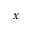<formula> <loc_0><loc_0><loc_500><loc_500>x</formula> 